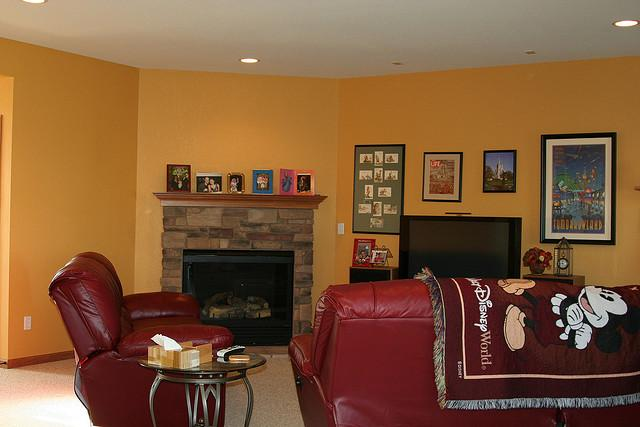What natural element might be found here? Please explain your reasoning. fire. There is a wood burning fireplace in the room. 